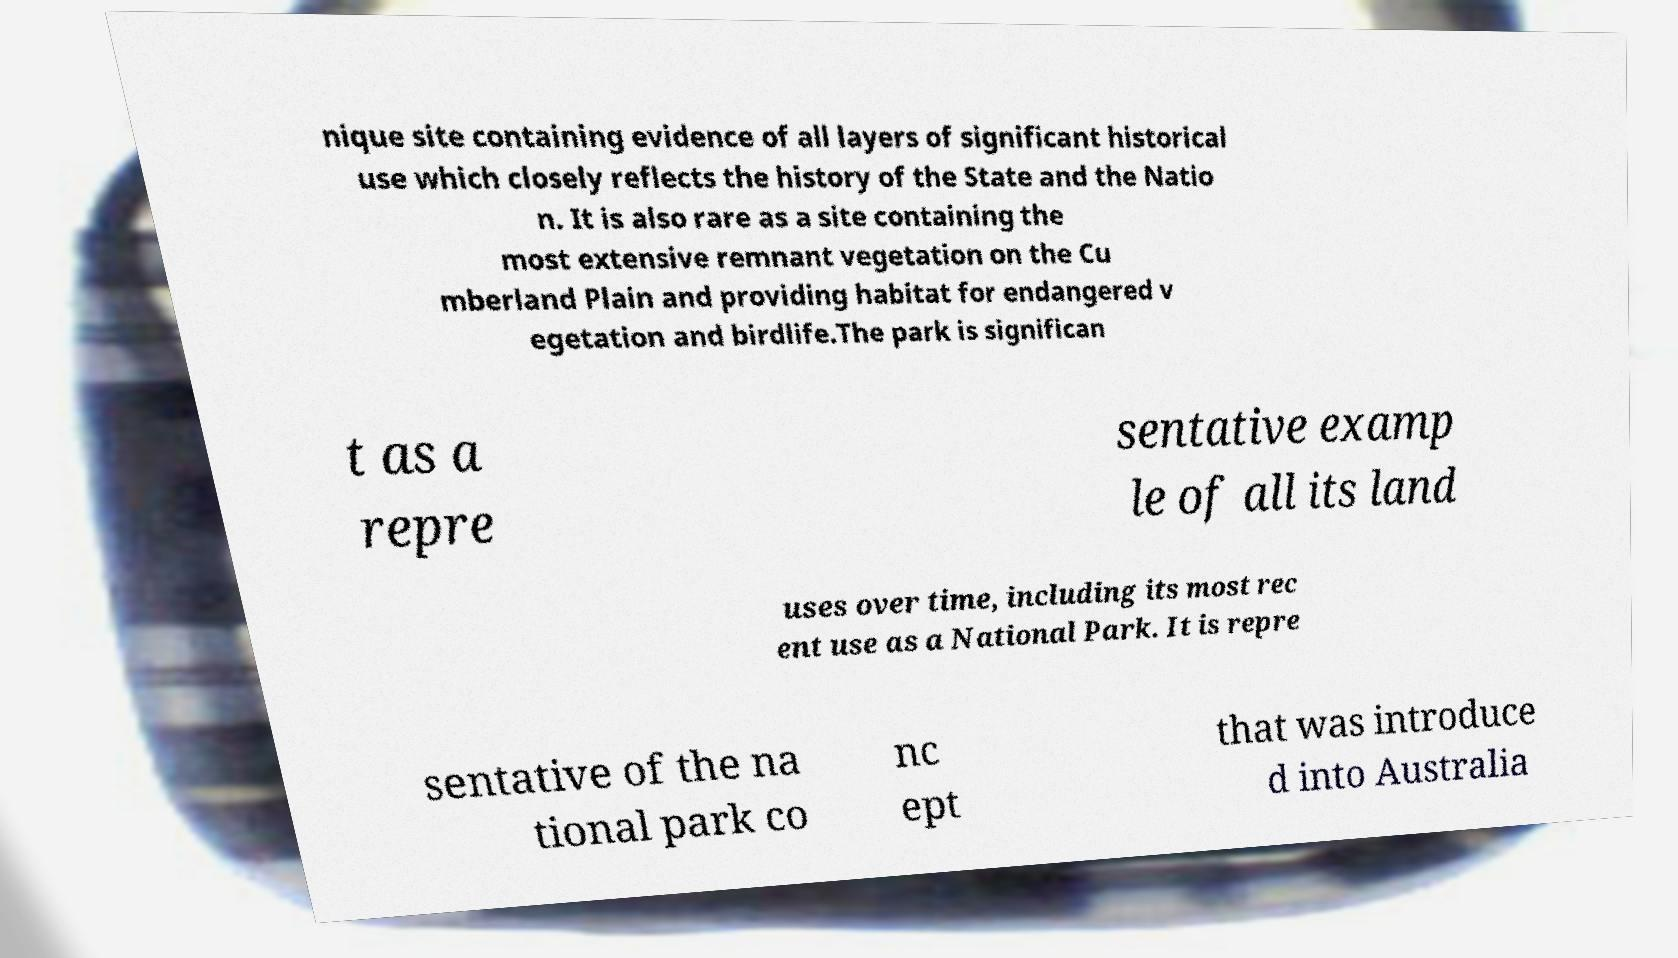Can you read and provide the text displayed in the image?This photo seems to have some interesting text. Can you extract and type it out for me? nique site containing evidence of all layers of significant historical use which closely reflects the history of the State and the Natio n. It is also rare as a site containing the most extensive remnant vegetation on the Cu mberland Plain and providing habitat for endangered v egetation and birdlife.The park is significan t as a repre sentative examp le of all its land uses over time, including its most rec ent use as a National Park. It is repre sentative of the na tional park co nc ept that was introduce d into Australia 